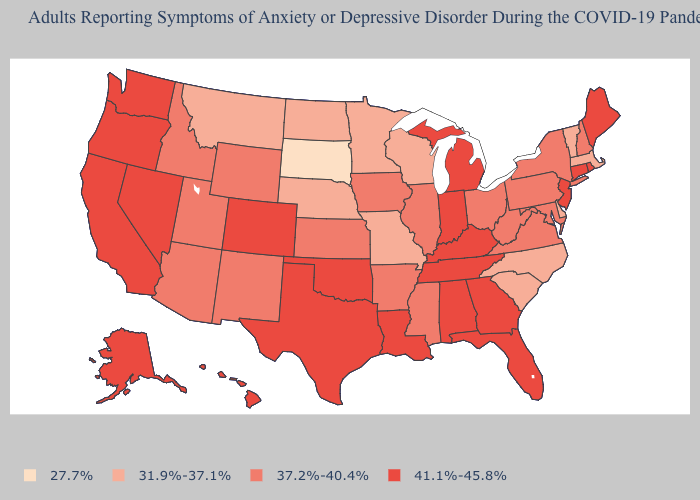Does Maine have the lowest value in the Northeast?
Be succinct. No. What is the value of Vermont?
Write a very short answer. 31.9%-37.1%. What is the value of Vermont?
Write a very short answer. 31.9%-37.1%. Is the legend a continuous bar?
Give a very brief answer. No. Among the states that border Nevada , which have the highest value?
Be succinct. California, Oregon. Which states have the highest value in the USA?
Quick response, please. Alabama, Alaska, California, Colorado, Connecticut, Florida, Georgia, Hawaii, Indiana, Kentucky, Louisiana, Maine, Michigan, Nevada, New Jersey, Oklahoma, Oregon, Rhode Island, Tennessee, Texas, Washington. What is the value of New Hampshire?
Quick response, please. 37.2%-40.4%. Name the states that have a value in the range 27.7%?
Be succinct. South Dakota. How many symbols are there in the legend?
Give a very brief answer. 4. Which states hav the highest value in the West?
Concise answer only. Alaska, California, Colorado, Hawaii, Nevada, Oregon, Washington. How many symbols are there in the legend?
Short answer required. 4. Name the states that have a value in the range 27.7%?
Write a very short answer. South Dakota. What is the value of New Jersey?
Short answer required. 41.1%-45.8%. Does the first symbol in the legend represent the smallest category?
Be succinct. Yes. Name the states that have a value in the range 27.7%?
Quick response, please. South Dakota. 